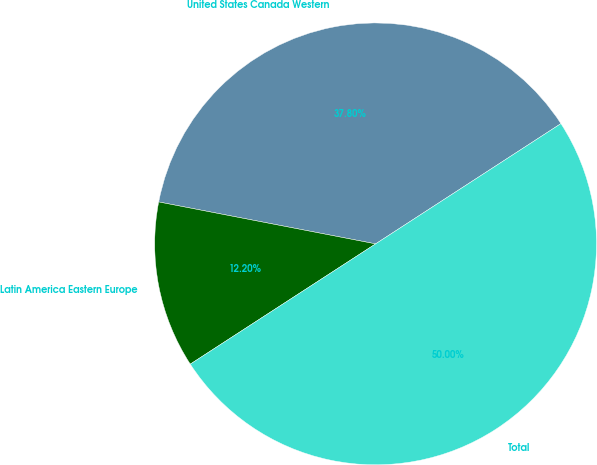<chart> <loc_0><loc_0><loc_500><loc_500><pie_chart><fcel>United States Canada Western<fcel>Latin America Eastern Europe<fcel>Total<nl><fcel>37.8%<fcel>12.2%<fcel>50.0%<nl></chart> 